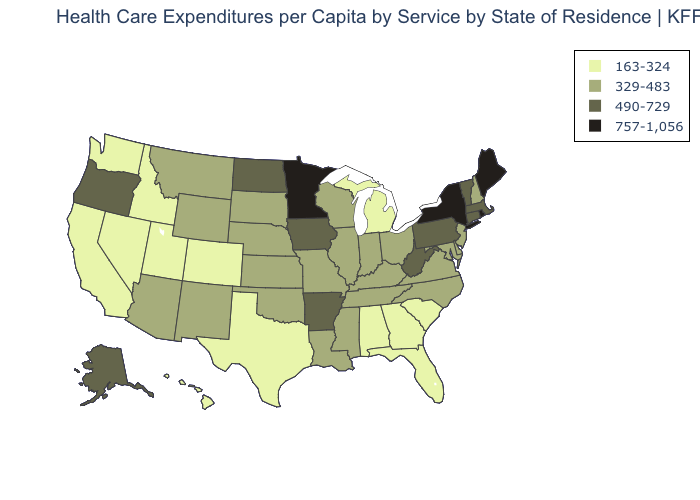Among the states that border New Hampshire , does Vermont have the highest value?
Answer briefly. No. Does the map have missing data?
Quick response, please. No. Which states have the lowest value in the USA?
Quick response, please. Alabama, California, Colorado, Florida, Georgia, Hawaii, Idaho, Michigan, Nevada, South Carolina, Texas, Utah, Washington. What is the lowest value in the USA?
Concise answer only. 163-324. What is the highest value in the MidWest ?
Short answer required. 757-1,056. Does Delaware have a lower value than Alaska?
Write a very short answer. Yes. How many symbols are there in the legend?
Be succinct. 4. Name the states that have a value in the range 490-729?
Be succinct. Alaska, Arkansas, Connecticut, Iowa, Massachusetts, North Dakota, Oregon, Pennsylvania, Vermont, West Virginia. What is the value of Georgia?
Write a very short answer. 163-324. Does the first symbol in the legend represent the smallest category?
Short answer required. Yes. Is the legend a continuous bar?
Concise answer only. No. What is the lowest value in the Northeast?
Write a very short answer. 329-483. What is the highest value in the South ?
Short answer required. 490-729. What is the value of Texas?
Keep it brief. 163-324. Is the legend a continuous bar?
Concise answer only. No. 